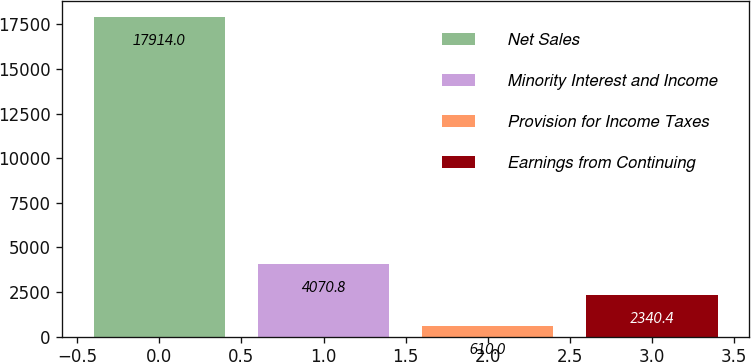Convert chart to OTSL. <chart><loc_0><loc_0><loc_500><loc_500><bar_chart><fcel>Net Sales<fcel>Minority Interest and Income<fcel>Provision for Income Taxes<fcel>Earnings from Continuing<nl><fcel>17914<fcel>4070.8<fcel>610<fcel>2340.4<nl></chart> 